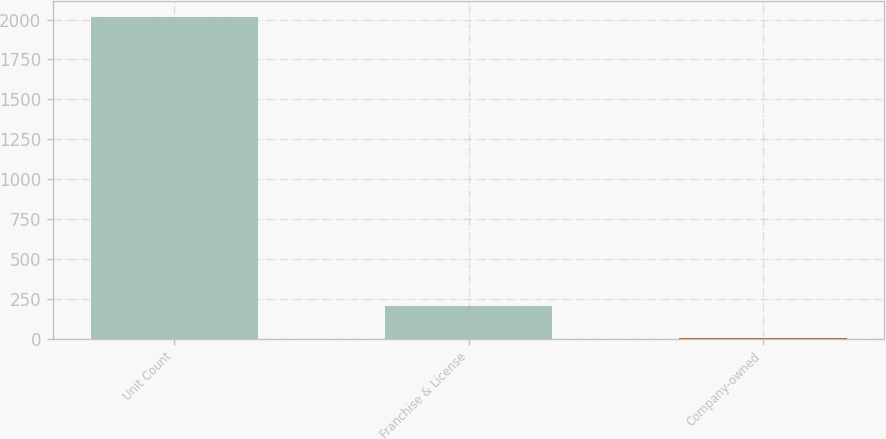<chart> <loc_0><loc_0><loc_500><loc_500><bar_chart><fcel>Unit Count<fcel>Franchise & License<fcel>Company-owned<nl><fcel>2015<fcel>204.2<fcel>3<nl></chart> 